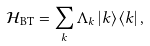<formula> <loc_0><loc_0><loc_500><loc_500>\mathcal { H } _ { \text {BT} } = \sum _ { k } \Lambda _ { k } \left | k \right \rangle \left \langle k \right | ,</formula> 